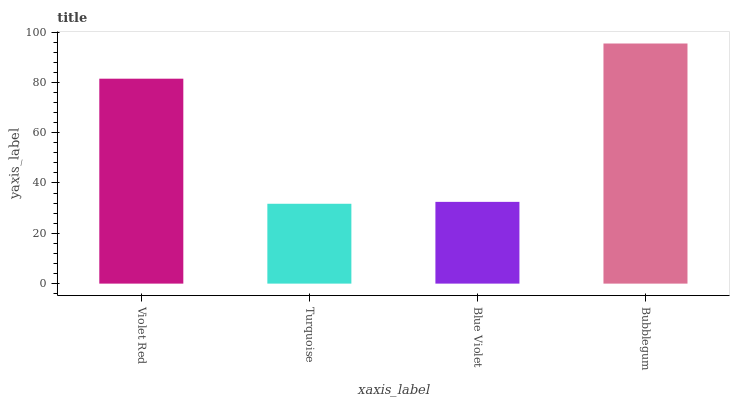Is Blue Violet the minimum?
Answer yes or no. No. Is Blue Violet the maximum?
Answer yes or no. No. Is Blue Violet greater than Turquoise?
Answer yes or no. Yes. Is Turquoise less than Blue Violet?
Answer yes or no. Yes. Is Turquoise greater than Blue Violet?
Answer yes or no. No. Is Blue Violet less than Turquoise?
Answer yes or no. No. Is Violet Red the high median?
Answer yes or no. Yes. Is Blue Violet the low median?
Answer yes or no. Yes. Is Blue Violet the high median?
Answer yes or no. No. Is Bubblegum the low median?
Answer yes or no. No. 